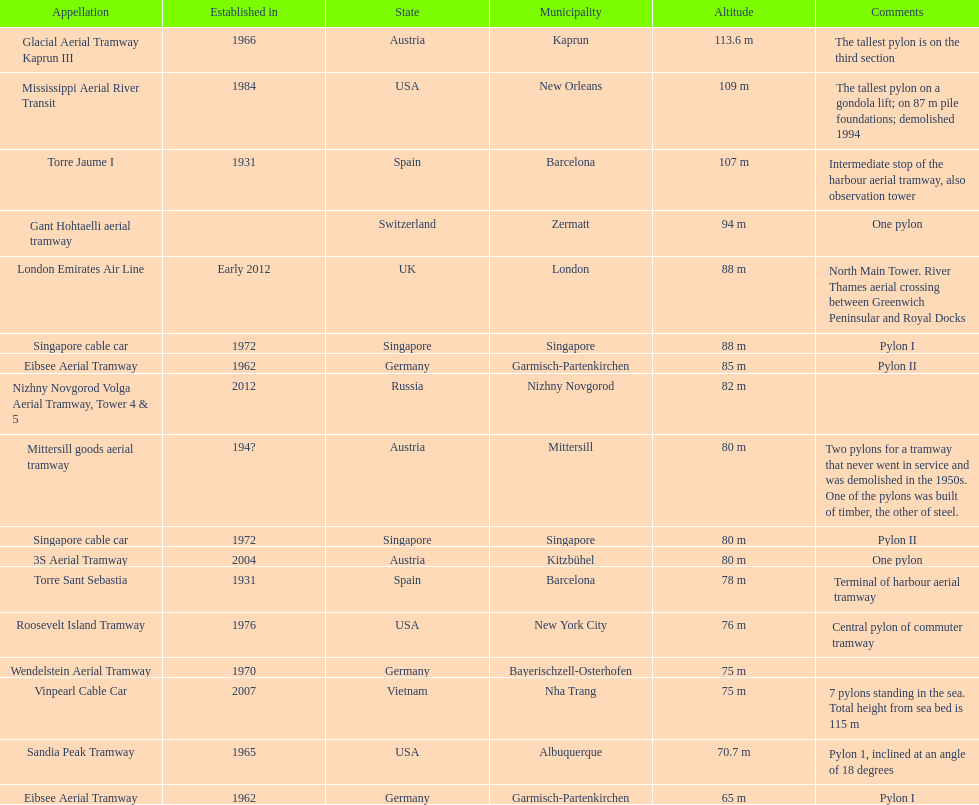What is the total number of tallest pylons in austria? 3. 